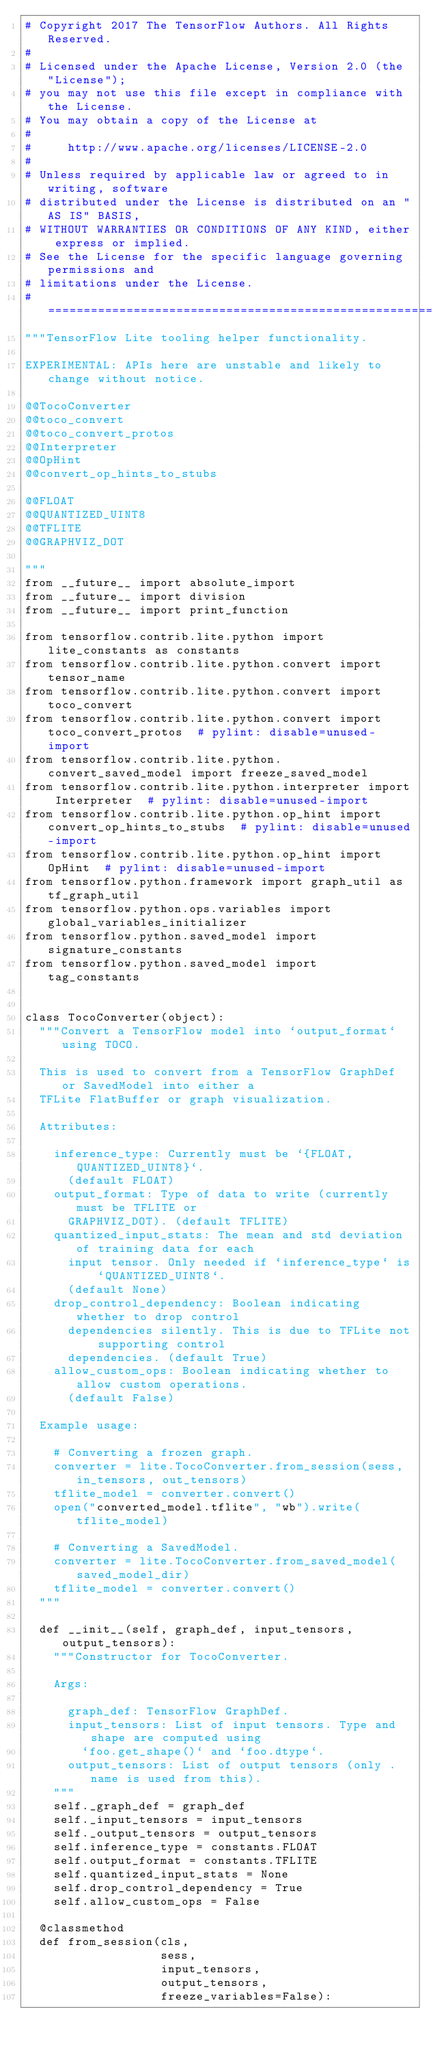Convert code to text. <code><loc_0><loc_0><loc_500><loc_500><_Python_># Copyright 2017 The TensorFlow Authors. All Rights Reserved.
#
# Licensed under the Apache License, Version 2.0 (the "License");
# you may not use this file except in compliance with the License.
# You may obtain a copy of the License at
#
#     http://www.apache.org/licenses/LICENSE-2.0
#
# Unless required by applicable law or agreed to in writing, software
# distributed under the License is distributed on an "AS IS" BASIS,
# WITHOUT WARRANTIES OR CONDITIONS OF ANY KIND, either express or implied.
# See the License for the specific language governing permissions and
# limitations under the License.
# ==============================================================================
"""TensorFlow Lite tooling helper functionality.

EXPERIMENTAL: APIs here are unstable and likely to change without notice.

@@TocoConverter
@@toco_convert
@@toco_convert_protos
@@Interpreter
@@OpHint
@@convert_op_hints_to_stubs

@@FLOAT
@@QUANTIZED_UINT8
@@TFLITE
@@GRAPHVIZ_DOT

"""
from __future__ import absolute_import
from __future__ import division
from __future__ import print_function

from tensorflow.contrib.lite.python import lite_constants as constants
from tensorflow.contrib.lite.python.convert import tensor_name
from tensorflow.contrib.lite.python.convert import toco_convert
from tensorflow.contrib.lite.python.convert import toco_convert_protos  # pylint: disable=unused-import
from tensorflow.contrib.lite.python.convert_saved_model import freeze_saved_model
from tensorflow.contrib.lite.python.interpreter import Interpreter  # pylint: disable=unused-import
from tensorflow.contrib.lite.python.op_hint import convert_op_hints_to_stubs  # pylint: disable=unused-import
from tensorflow.contrib.lite.python.op_hint import OpHint  # pylint: disable=unused-import
from tensorflow.python.framework import graph_util as tf_graph_util
from tensorflow.python.ops.variables import global_variables_initializer
from tensorflow.python.saved_model import signature_constants
from tensorflow.python.saved_model import tag_constants


class TocoConverter(object):
  """Convert a TensorFlow model into `output_format` using TOCO.

  This is used to convert from a TensorFlow GraphDef or SavedModel into either a
  TFLite FlatBuffer or graph visualization.

  Attributes:

    inference_type: Currently must be `{FLOAT, QUANTIZED_UINT8}`.
      (default FLOAT)
    output_format: Type of data to write (currently must be TFLITE or
      GRAPHVIZ_DOT). (default TFLITE)
    quantized_input_stats: The mean and std deviation of training data for each
      input tensor. Only needed if `inference_type` is `QUANTIZED_UINT8`.
      (default None)
    drop_control_dependency: Boolean indicating whether to drop control
      dependencies silently. This is due to TFLite not supporting control
      dependencies. (default True)
    allow_custom_ops: Boolean indicating whether to allow custom operations.
      (default False)

  Example usage:

    # Converting a frozen graph.
    converter = lite.TocoConverter.from_session(sess, in_tensors, out_tensors)
    tflite_model = converter.convert()
    open("converted_model.tflite", "wb").write(tflite_model)

    # Converting a SavedModel.
    converter = lite.TocoConverter.from_saved_model(saved_model_dir)
    tflite_model = converter.convert()
  """

  def __init__(self, graph_def, input_tensors, output_tensors):
    """Constructor for TocoConverter.

    Args:

      graph_def: TensorFlow GraphDef.
      input_tensors: List of input tensors. Type and shape are computed using
        `foo.get_shape()` and `foo.dtype`.
      output_tensors: List of output tensors (only .name is used from this).
    """
    self._graph_def = graph_def
    self._input_tensors = input_tensors
    self._output_tensors = output_tensors
    self.inference_type = constants.FLOAT
    self.output_format = constants.TFLITE
    self.quantized_input_stats = None
    self.drop_control_dependency = True
    self.allow_custom_ops = False

  @classmethod
  def from_session(cls,
                   sess,
                   input_tensors,
                   output_tensors,
                   freeze_variables=False):</code> 